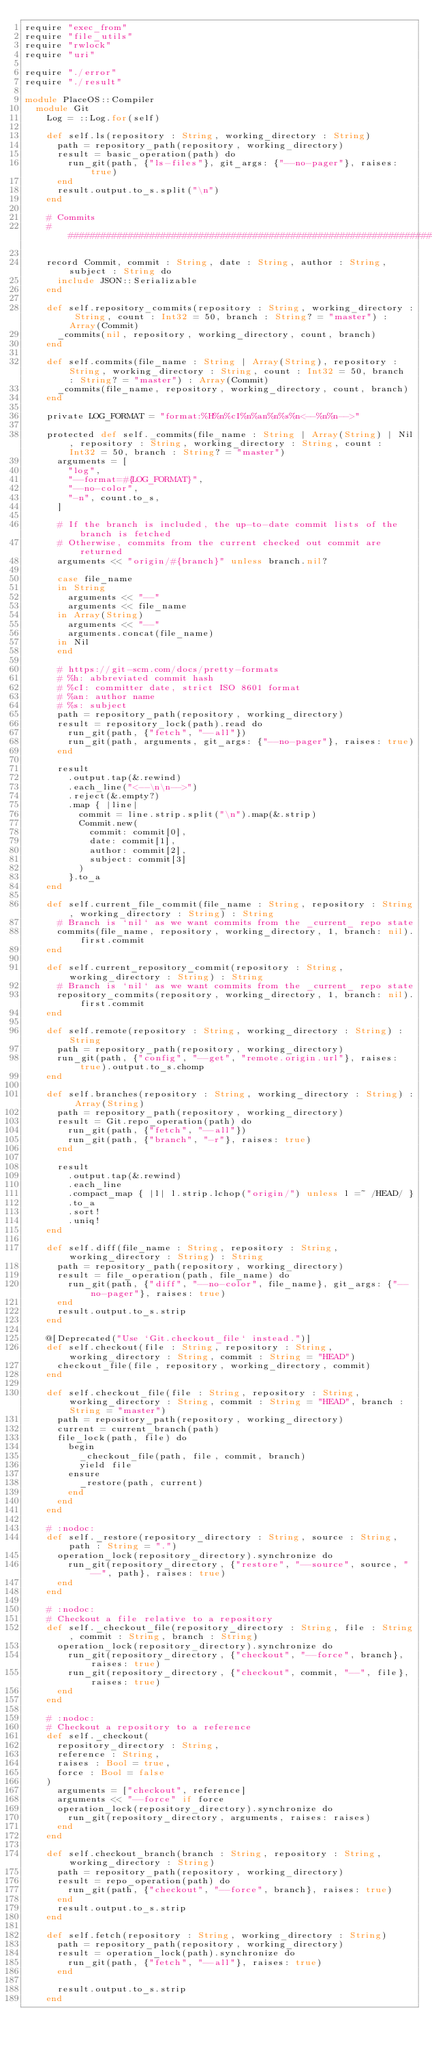<code> <loc_0><loc_0><loc_500><loc_500><_Crystal_>require "exec_from"
require "file_utils"
require "rwlock"
require "uri"

require "./error"
require "./result"

module PlaceOS::Compiler
  module Git
    Log = ::Log.for(self)

    def self.ls(repository : String, working_directory : String)
      path = repository_path(repository, working_directory)
      result = basic_operation(path) do
        run_git(path, {"ls-files"}, git_args: {"--no-pager"}, raises: true)
      end
      result.output.to_s.split("\n")
    end

    # Commits
    ###############################################################################################

    record Commit, commit : String, date : String, author : String, subject : String do
      include JSON::Serializable
    end

    def self.repository_commits(repository : String, working_directory : String, count : Int32 = 50, branch : String? = "master") : Array(Commit)
      _commits(nil, repository, working_directory, count, branch)
    end

    def self.commits(file_name : String | Array(String), repository : String, working_directory : String, count : Int32 = 50, branch : String? = "master") : Array(Commit)
      _commits(file_name, repository, working_directory, count, branch)
    end

    private LOG_FORMAT = "format:%H%n%cI%n%an%n%s%n<--%n%n-->"

    protected def self._commits(file_name : String | Array(String) | Nil, repository : String, working_directory : String, count : Int32 = 50, branch : String? = "master")
      arguments = [
        "log",
        "--format=#{LOG_FORMAT}",
        "--no-color",
        "-n", count.to_s,
      ]

      # If the branch is included, the up-to-date commit lists of the branch is fetched
      # Otherwise, commits from the current checked out commit are returned
      arguments << "origin/#{branch}" unless branch.nil?

      case file_name
      in String
        arguments << "--"
        arguments << file_name
      in Array(String)
        arguments << "--"
        arguments.concat(file_name)
      in Nil
      end

      # https://git-scm.com/docs/pretty-formats
      # %h: abbreviated commit hash
      # %cI: committer date, strict ISO 8601 format
      # %an: author name
      # %s: subject
      path = repository_path(repository, working_directory)
      result = repository_lock(path).read do
        run_git(path, {"fetch", "--all"})
        run_git(path, arguments, git_args: {"--no-pager"}, raises: true)
      end

      result
        .output.tap(&.rewind)
        .each_line("<--\n\n-->")
        .reject(&.empty?)
        .map { |line|
          commit = line.strip.split("\n").map(&.strip)
          Commit.new(
            commit: commit[0],
            date: commit[1],
            author: commit[2],
            subject: commit[3]
          )
        }.to_a
    end

    def self.current_file_commit(file_name : String, repository : String, working_directory : String) : String
      # Branch is `nil` as we want commits from the _current_ repo state
      commits(file_name, repository, working_directory, 1, branch: nil).first.commit
    end

    def self.current_repository_commit(repository : String, working_directory : String) : String
      # Branch is `nil` as we want commits from the _current_ repo state
      repository_commits(repository, working_directory, 1, branch: nil).first.commit
    end

    def self.remote(repository : String, working_directory : String) : String
      path = repository_path(repository, working_directory)
      run_git(path, {"config", "--get", "remote.origin.url"}, raises: true).output.to_s.chomp
    end

    def self.branches(repository : String, working_directory : String) : Array(String)
      path = repository_path(repository, working_directory)
      result = Git.repo_operation(path) do
        run_git(path, {"fetch", "--all"})
        run_git(path, {"branch", "-r"}, raises: true)
      end

      result
        .output.tap(&.rewind)
        .each_line
        .compact_map { |l| l.strip.lchop("origin/") unless l =~ /HEAD/ }
        .to_a
        .sort!
        .uniq!
    end

    def self.diff(file_name : String, repository : String, working_directory : String) : String
      path = repository_path(repository, working_directory)
      result = file_operation(path, file_name) do
        run_git(path, {"diff", "--no-color", file_name}, git_args: {"--no-pager"}, raises: true)
      end
      result.output.to_s.strip
    end

    @[Deprecated("Use `Git.checkout_file` instead.")]
    def self.checkout(file : String, repository : String, working_directory : String, commit : String = "HEAD")
      checkout_file(file, repository, working_directory, commit)
    end

    def self.checkout_file(file : String, repository : String, working_directory : String, commit : String = "HEAD", branch : String = "master")
      path = repository_path(repository, working_directory)
      current = current_branch(path)
      file_lock(path, file) do
        begin
          _checkout_file(path, file, commit, branch)
          yield file
        ensure
          _restore(path, current)
        end
      end
    end

    # :nodoc:
    def self._restore(repository_directory : String, source : String, path : String = ".")
      operation_lock(repository_directory).synchronize do
        run_git(repository_directory, {"restore", "--source", source, "--", path}, raises: true)
      end
    end

    # :nodoc:
    # Checkout a file relative to a repository
    def self._checkout_file(repository_directory : String, file : String, commit : String, branch : String)
      operation_lock(repository_directory).synchronize do
        run_git(repository_directory, {"checkout", "--force", branch}, raises: true)
        run_git(repository_directory, {"checkout", commit, "--", file}, raises: true)
      end
    end

    # :nodoc:
    # Checkout a repository to a reference
    def self._checkout(
      repository_directory : String,
      reference : String,
      raises : Bool = true,
      force : Bool = false
    )
      arguments = ["checkout", reference]
      arguments << "--force" if force
      operation_lock(repository_directory).synchronize do
        run_git(repository_directory, arguments, raises: raises)
      end
    end

    def self.checkout_branch(branch : String, repository : String, working_directory : String)
      path = repository_path(repository, working_directory)
      result = repo_operation(path) do
        run_git(path, {"checkout", "--force", branch}, raises: true)
      end
      result.output.to_s.strip
    end

    def self.fetch(repository : String, working_directory : String)
      path = repository_path(repository, working_directory)
      result = operation_lock(path).synchronize do
        run_git(path, {"fetch", "--all"}, raises: true)
      end

      result.output.to_s.strip
    end
</code> 